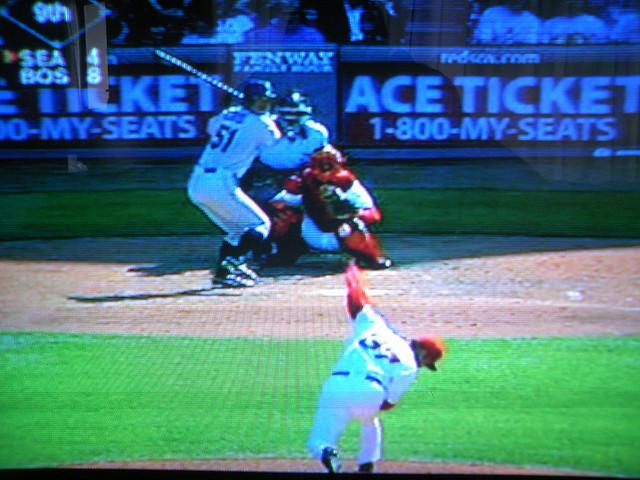What sport are they playing?
Write a very short answer. Baseball. What is the advertisement for?
Concise answer only. Ace tickets. Is this image taken from an electronic screen?
Keep it brief. Yes. 